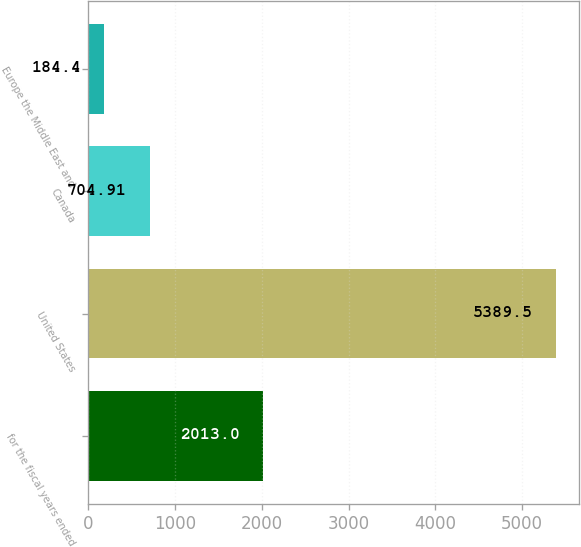<chart> <loc_0><loc_0><loc_500><loc_500><bar_chart><fcel>for the fiscal years ended<fcel>United States<fcel>Canada<fcel>Europe the Middle East and<nl><fcel>2013<fcel>5389.5<fcel>704.91<fcel>184.4<nl></chart> 